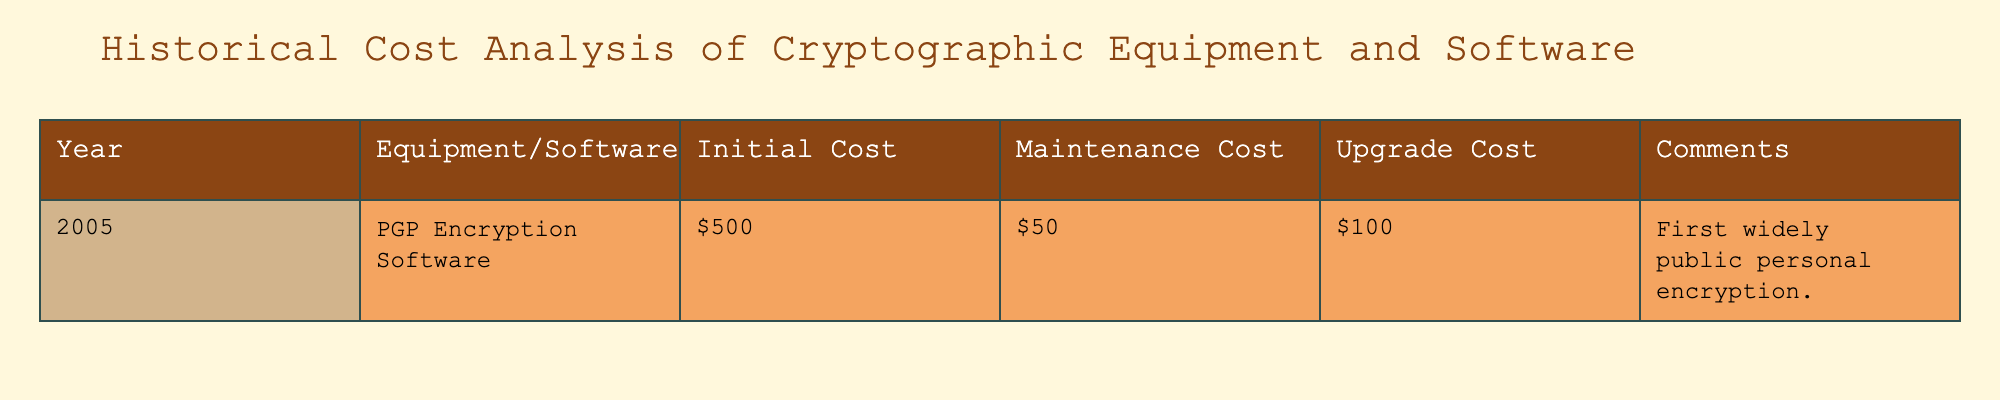What was the initial cost of the PGP Encryption Software in 2005? The initial cost of PGP Encryption Software is directly listed under the "Initial Cost" column for the year 2005, which is $500.
Answer: $500 What is the total annual cost (initial cost + maintenance cost) for the PGP Encryption Software in 2005? The total annual cost combines the initial cost of $500 with the maintenance cost of $50. Adding these gives $500 + $50 = $550.
Answer: $550 Did the PGP Encryption Software require any upgrade costs in 2005? The table shows an upgrade cost of $100 for the PGP Encryption Software in 2005, indicating that costs for upgrades were indeed required.
Answer: Yes What is the total combined cost (initial + maintenance + upgrade) for the PGP Encryption Software in 2005? The combined cost includes the initial cost of $500, the maintenance cost of $50, and the upgrade cost of $100. Summing these gives $500 + $50 + $100 = $650.
Answer: $650 Is the maintenance cost for the PGP Encryption Software higher than $40? The maintenance cost is $50, which is greater than $40, confirming that the statement is true.
Answer: Yes What can be inferred about the significance of the PGP Encryption Software in 2005 based on its comments? The comment states it was the first widely public personal encryption, suggesting its importance in making encryption accessible to the public, indicating a major milestone.
Answer: It was significant for public access to encryption Which has a higher cost associated with it, maintenance or upgrades for the PGP Encryption Software in 2005? The maintenance cost is $50, while the upgrade cost is $100. Since $100 (upgrade) is greater than $50 (maintenance), upgrades cost more.
Answer: Upgrades have a higher cost If a new version of the PGP Software were to be released in 2006 with an initial cost of $600, what would be the difference in initial cost compared to 2005? The initial cost for the new version in 2006 is $600, compared to the 2005 version's initial cost of $500. Thus, the difference is $600 - $500 = $100.
Answer: $100 Would the total cost for 2006 (assuming all other costs remain the same as 2005) exceed $700? If the initial cost in 2006 is $600 with maintenance of $50 and upgrades of $100, the total cost would be $600 + $50 + $100 = $750, which exceeds $700.
Answer: Yes 